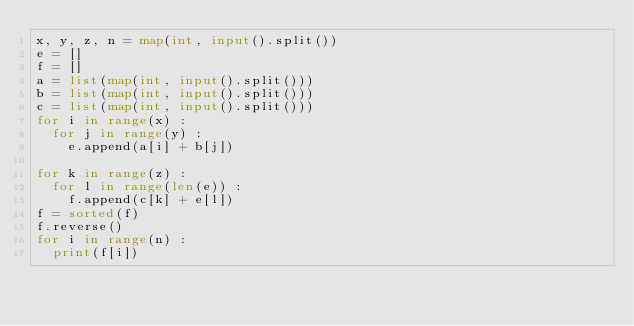Convert code to text. <code><loc_0><loc_0><loc_500><loc_500><_Python_>x, y, z, n = map(int, input().split())
e = []
f = []
a = list(map(int, input().split()))
b = list(map(int, input().split()))
c = list(map(int, input().split()))
for i in range(x) :
  for j in range(y) :
    e.append(a[i] + b[j])

for k in range(z) :
  for l in range(len(e)) :
    f.append(c[k] + e[l])
f = sorted(f)
f.reverse()
for i in range(n) :
  print(f[i])</code> 